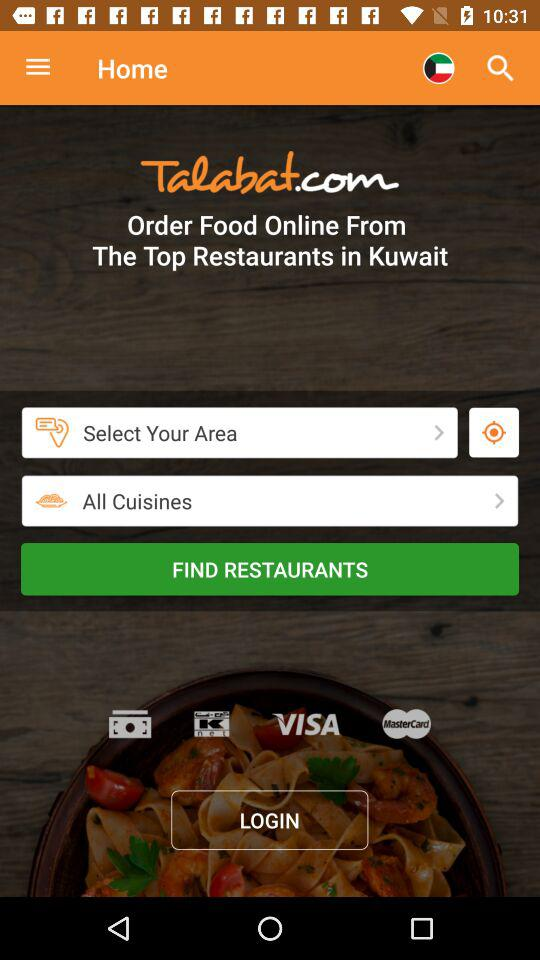What is the name of the restaurant?
When the provided information is insufficient, respond with <no answer>. <no answer> 